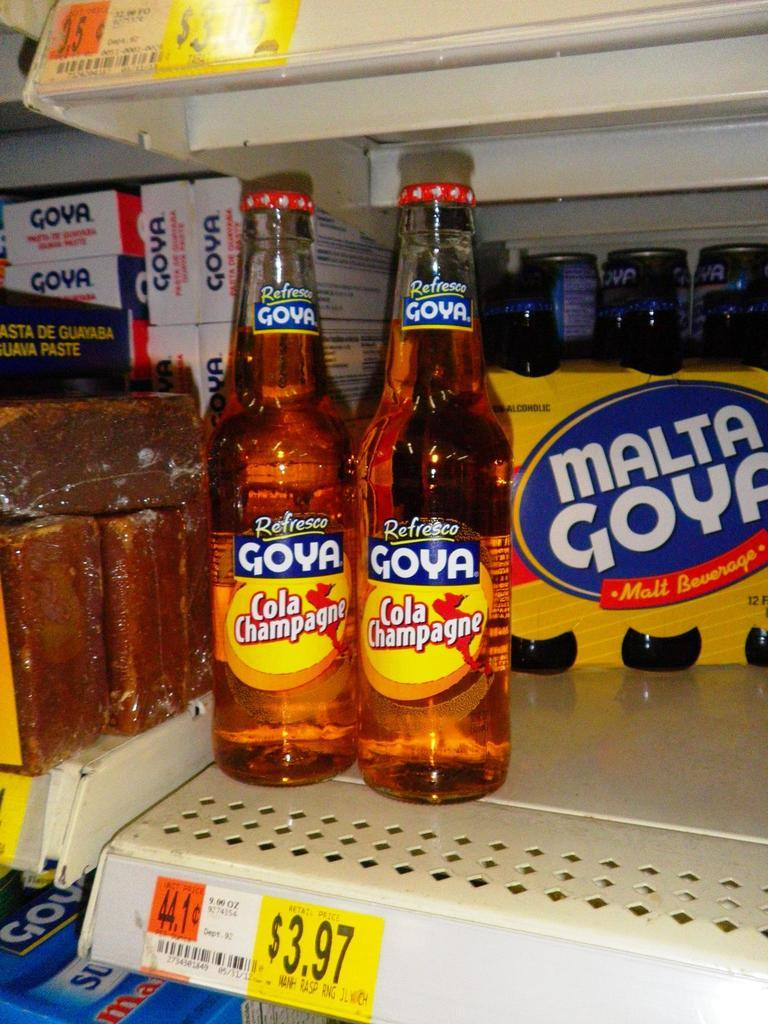<image>
Create a compact narrative representing the image presented. Two bottles of Goya Cola Champagne on a shelf next to other malt beverages. 